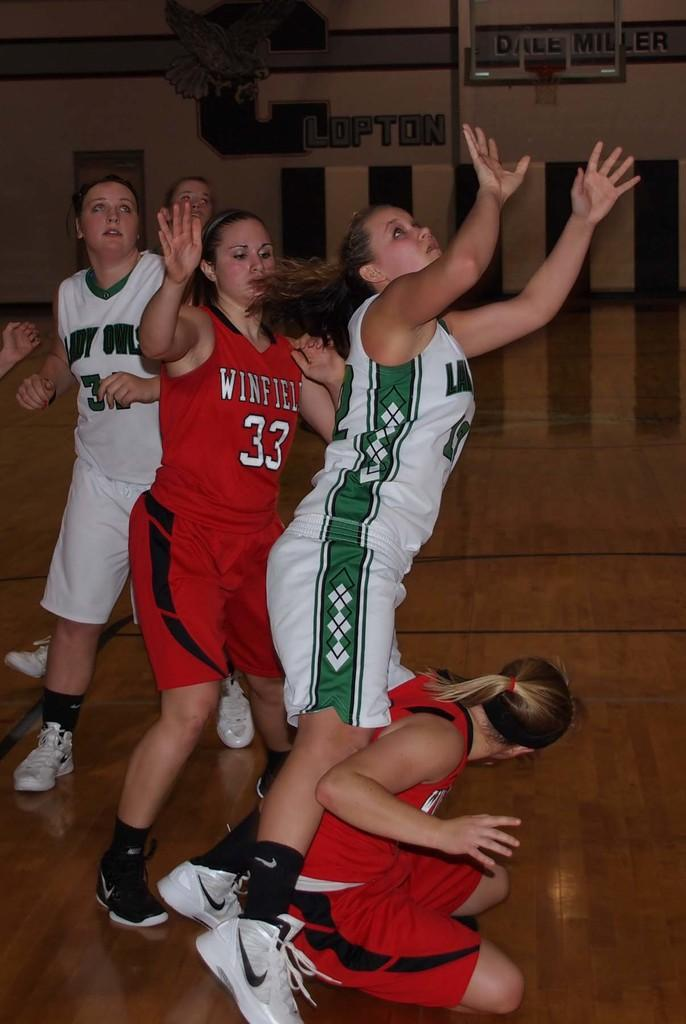<image>
Present a compact description of the photo's key features. Girls playing ball on a court and one has a 33 on her jersey. 